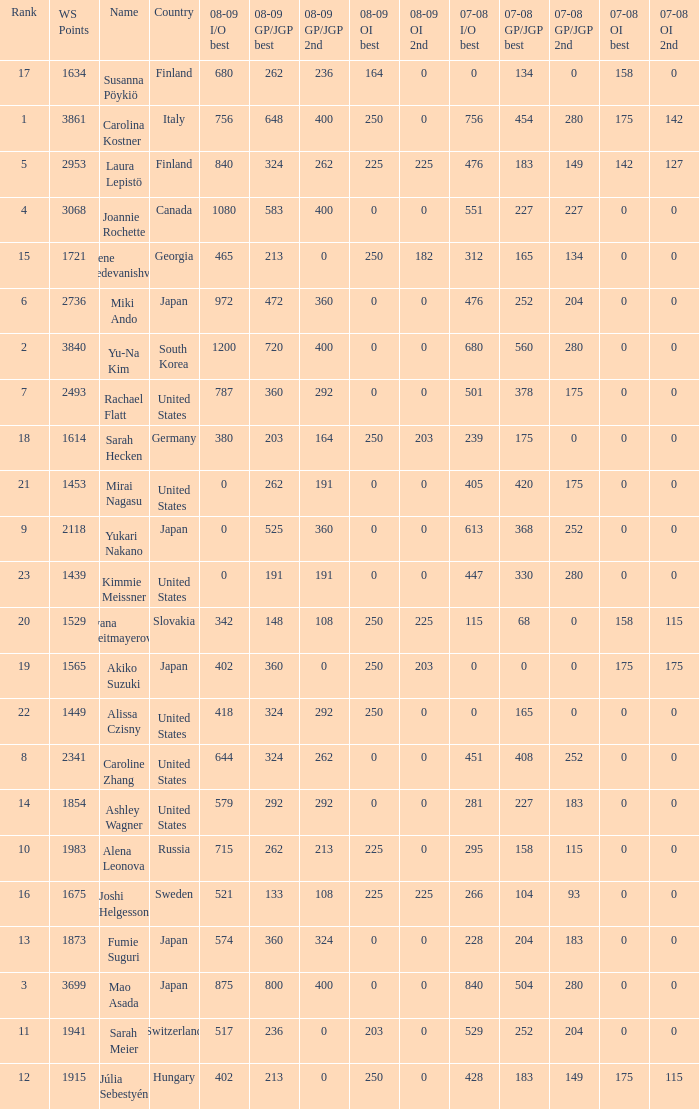What is the total 07-08 gp/jgp 2nd with the name mao asada 280.0. 